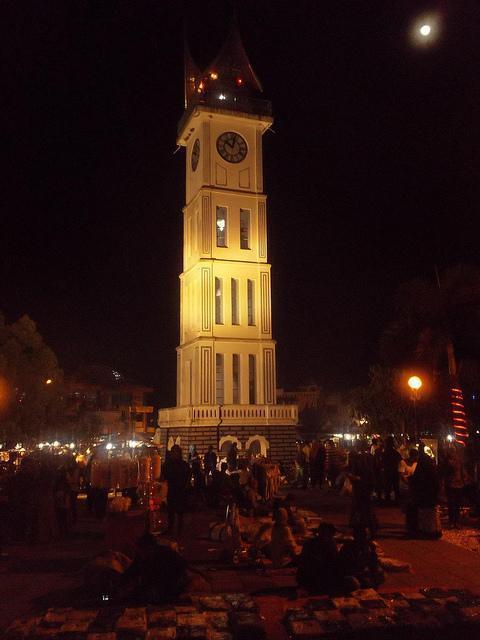How many people can be seen?
Give a very brief answer. 2. 